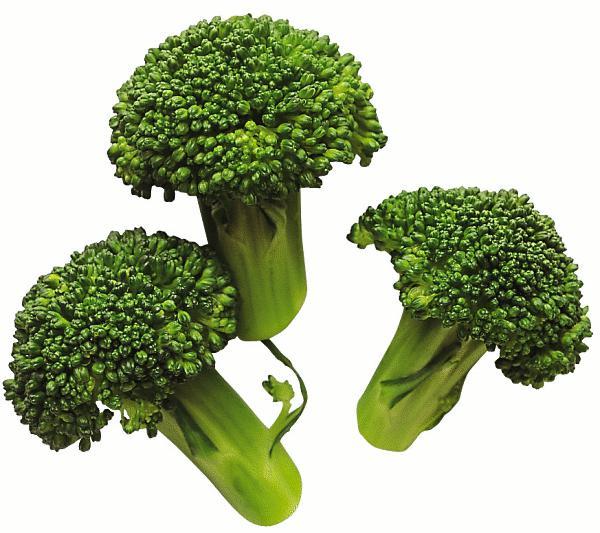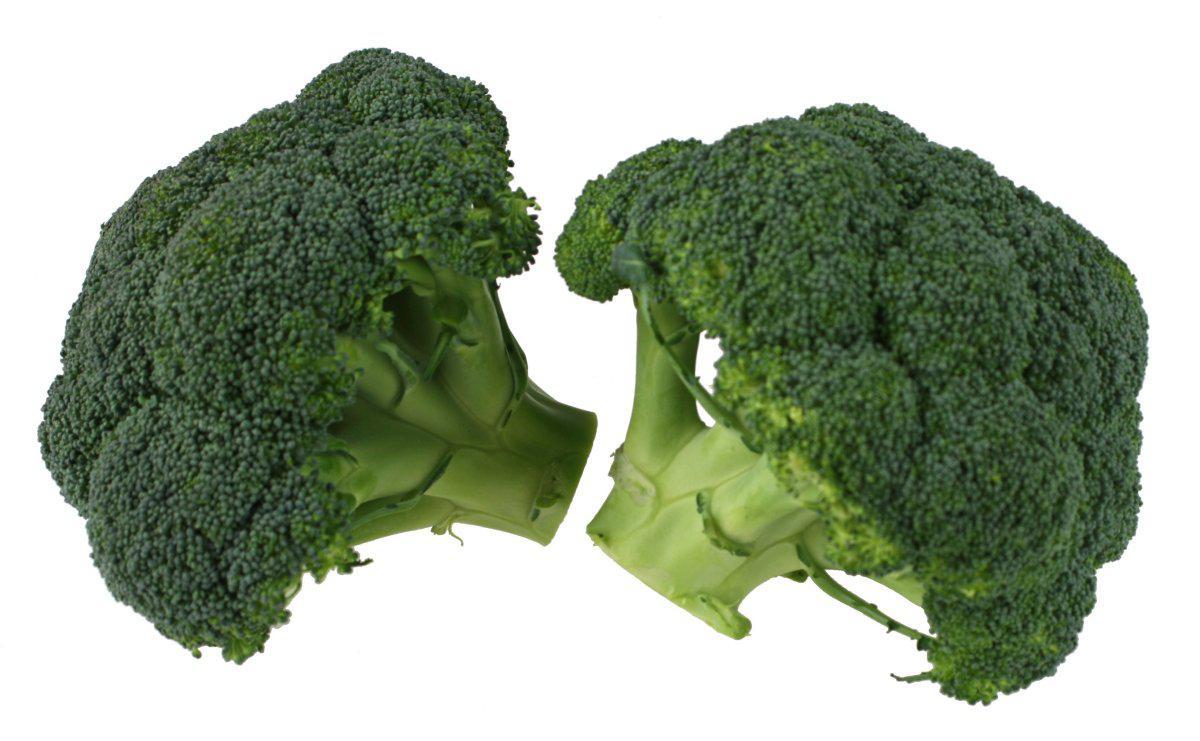The first image is the image on the left, the second image is the image on the right. For the images displayed, is the sentence "One image shows broccoli florets that are on some type of roundish item." factually correct? Answer yes or no. No. The first image is the image on the left, the second image is the image on the right. Examine the images to the left and right. Is the description "All of the images only feature broccoli pieces and nothing else." accurate? Answer yes or no. Yes. 